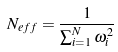<formula> <loc_0><loc_0><loc_500><loc_500>N _ { e f f } = \frac { 1 } { \sum _ { i = 1 } ^ { N } \omega _ { i } ^ { 2 } }</formula> 